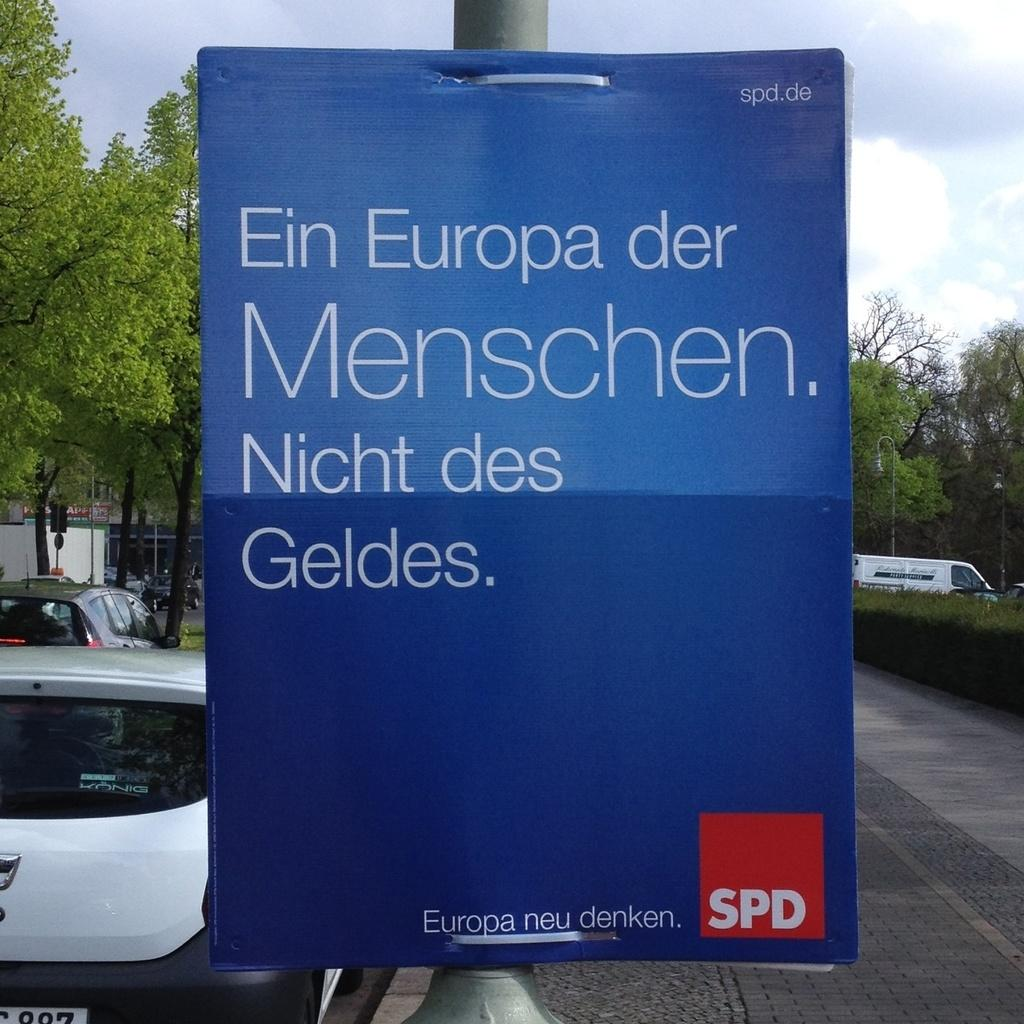What is located in the foreground of the image? There is a blue board in the foreground of the image. What is happening on the road in the image? Vehicles are moving on the road in the image. What can be seen in the background of the image? There are trees, buildings, and a sign board in the background of the image. What is the condition of the sky in the image? The sky is cloudy in the image. What type of furniture can be seen hanging from the trees in the image? There is no furniture hanging from the trees in the image; only trees, buildings, and a sign board are present in the background. Are there any kites visible in the image? There are no kites present in the image. 